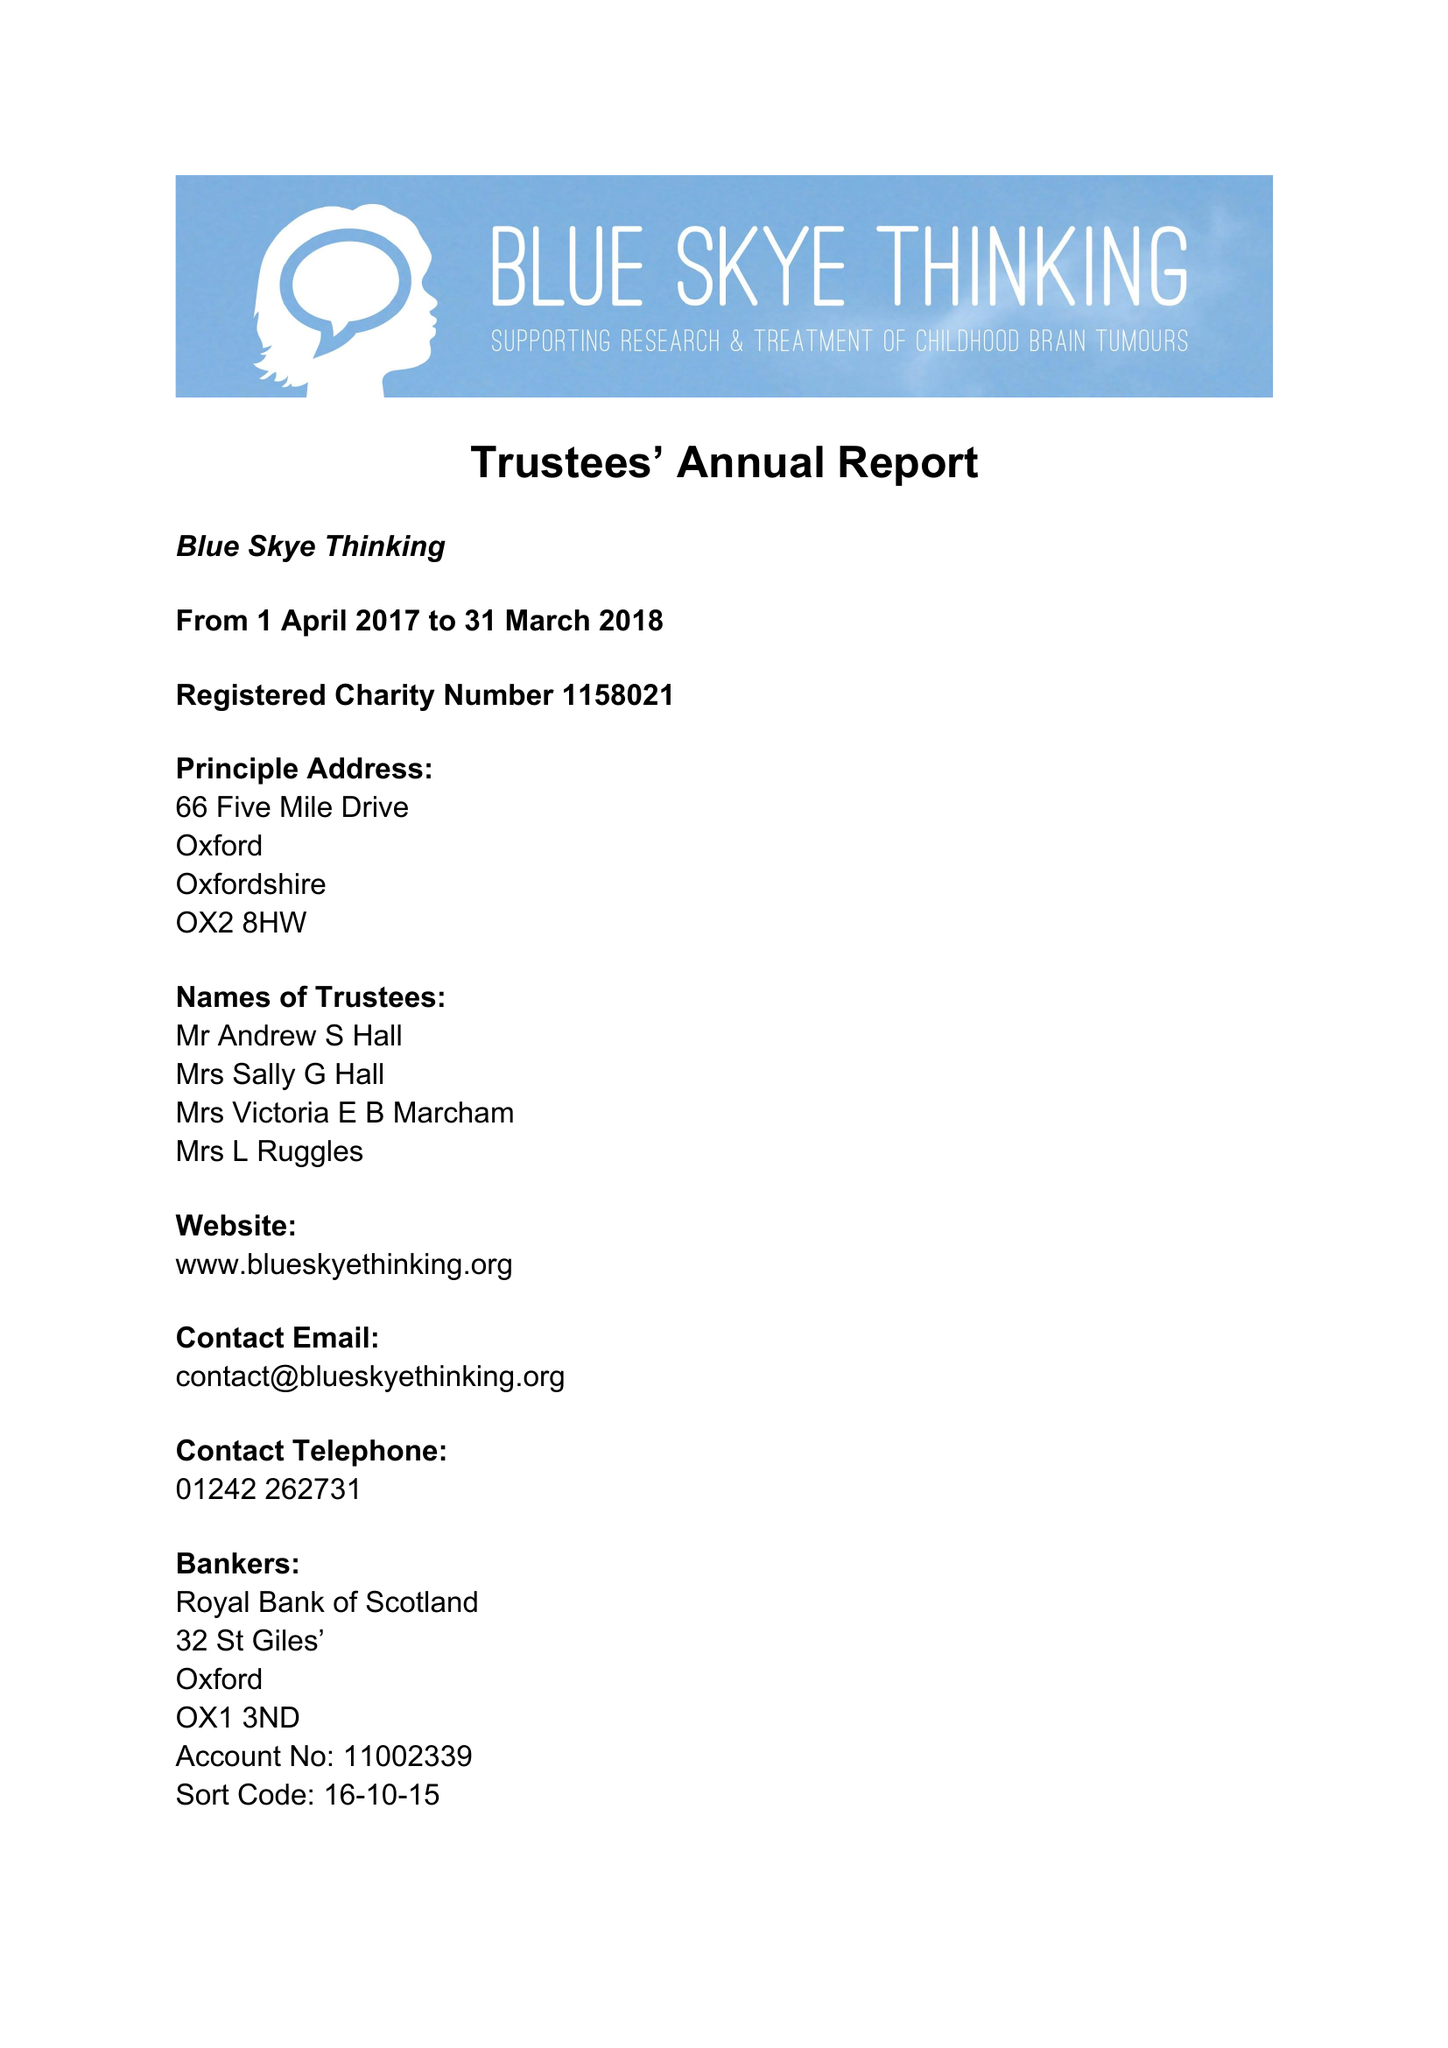What is the value for the address__postcode?
Answer the question using a single word or phrase. OX2 8HW 